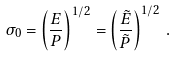<formula> <loc_0><loc_0><loc_500><loc_500>\sigma _ { 0 } = \left ( \frac { E } { P } \right ) ^ { 1 / 2 } = \left ( \frac { \tilde { E } } { \tilde { P } } \right ) ^ { 1 / 2 } \, .</formula> 